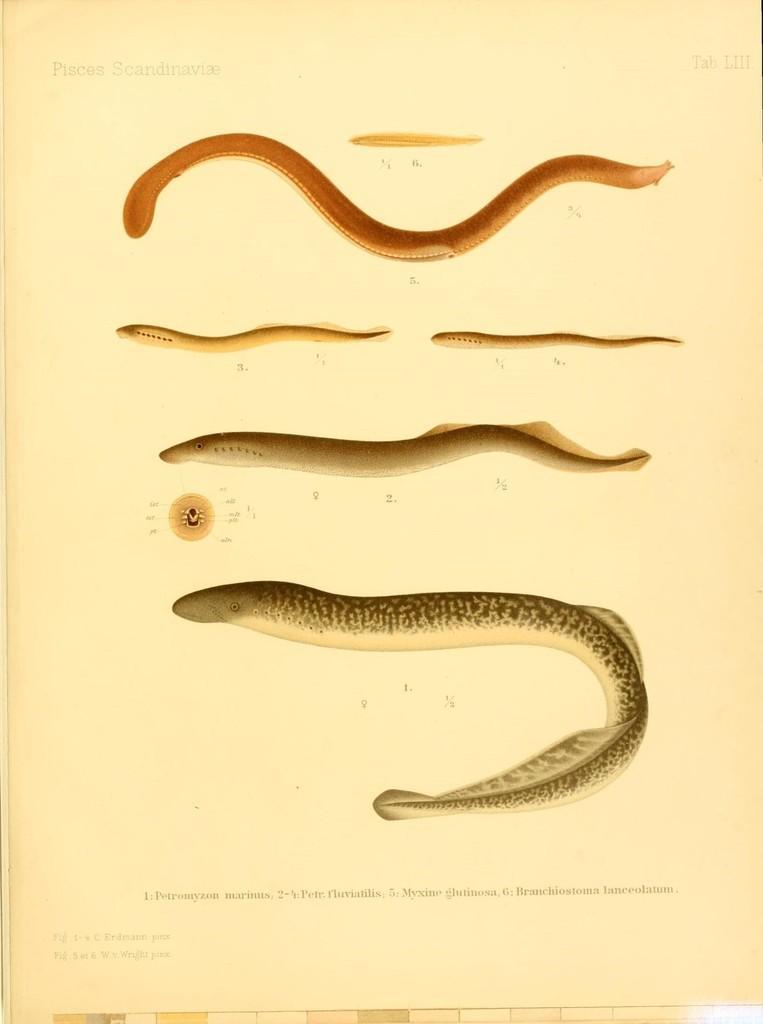Could you give a brief overview of what you see in this image? In this image I can see a paper. And on the paper there are images, numbers and some words on it. 